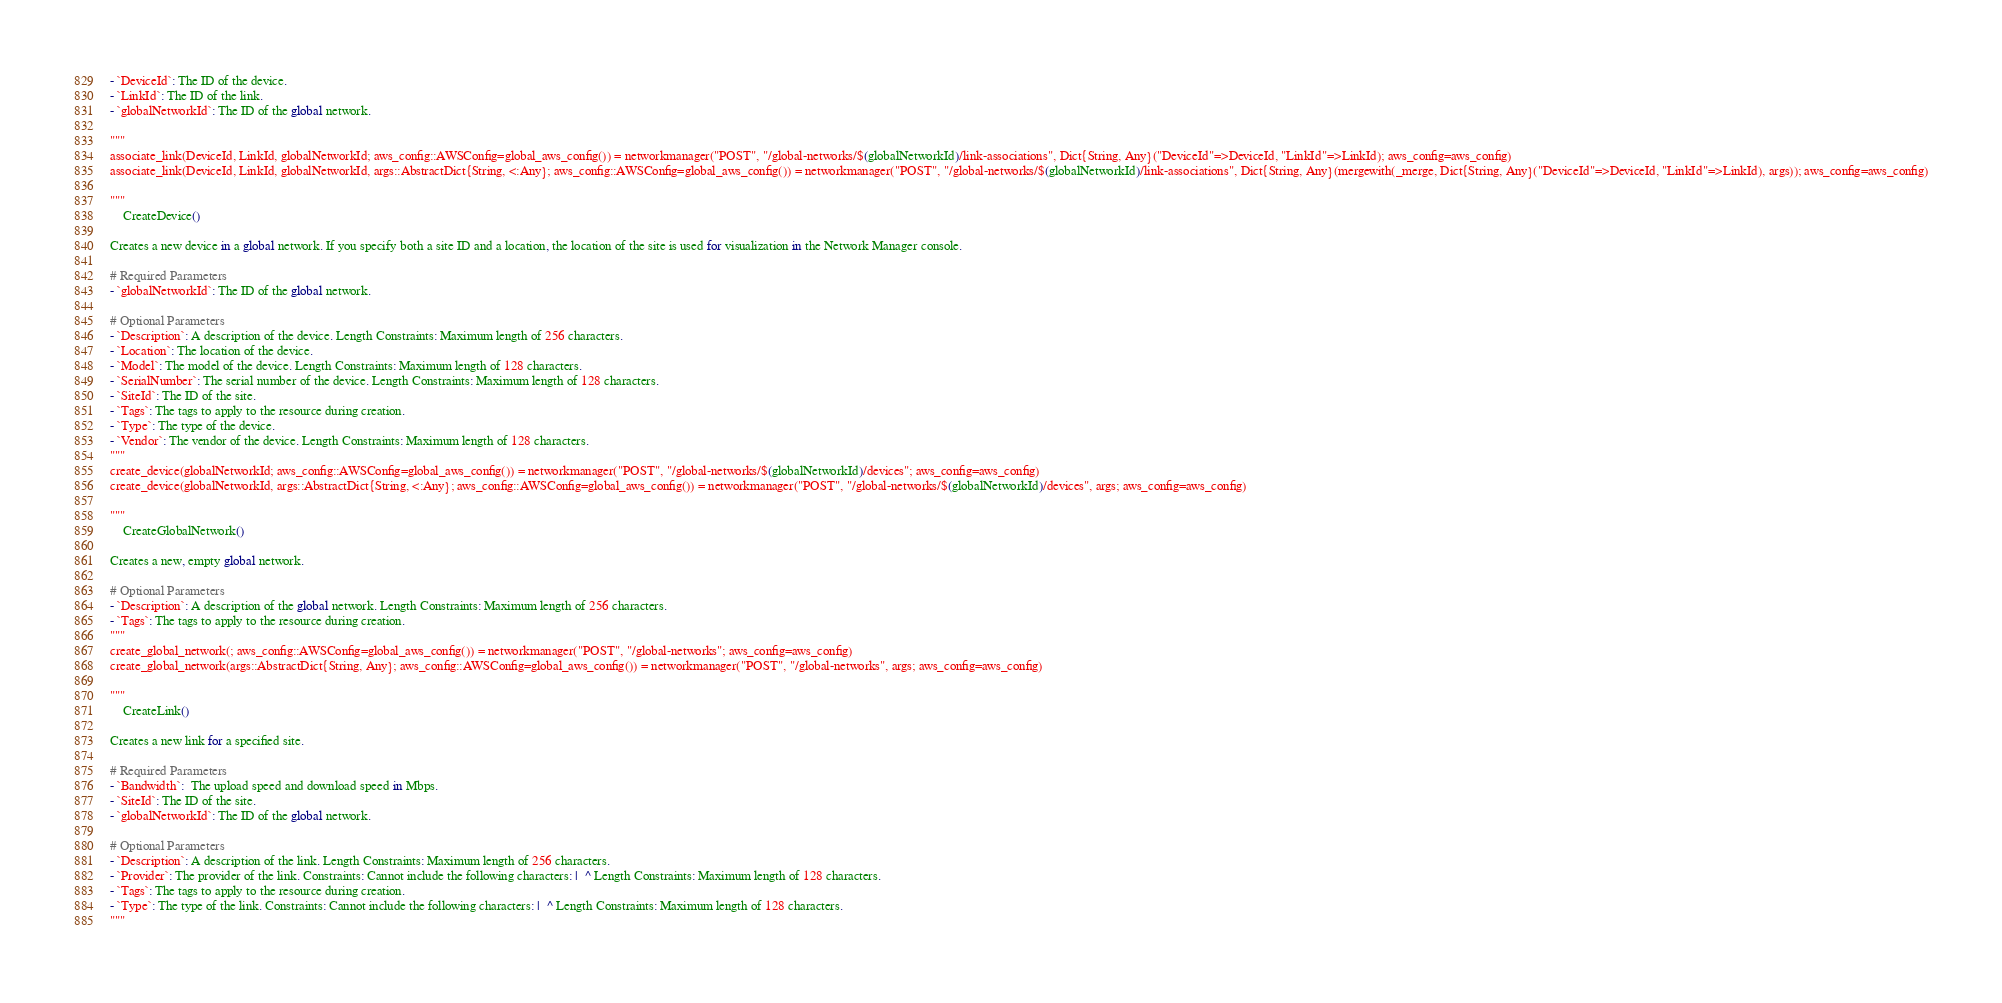Convert code to text. <code><loc_0><loc_0><loc_500><loc_500><_Julia_>- `DeviceId`: The ID of the device.
- `LinkId`: The ID of the link.
- `globalNetworkId`: The ID of the global network.

"""
associate_link(DeviceId, LinkId, globalNetworkId; aws_config::AWSConfig=global_aws_config()) = networkmanager("POST", "/global-networks/$(globalNetworkId)/link-associations", Dict{String, Any}("DeviceId"=>DeviceId, "LinkId"=>LinkId); aws_config=aws_config)
associate_link(DeviceId, LinkId, globalNetworkId, args::AbstractDict{String, <:Any}; aws_config::AWSConfig=global_aws_config()) = networkmanager("POST", "/global-networks/$(globalNetworkId)/link-associations", Dict{String, Any}(mergewith(_merge, Dict{String, Any}("DeviceId"=>DeviceId, "LinkId"=>LinkId), args)); aws_config=aws_config)

"""
    CreateDevice()

Creates a new device in a global network. If you specify both a site ID and a location, the location of the site is used for visualization in the Network Manager console.

# Required Parameters
- `globalNetworkId`: The ID of the global network.

# Optional Parameters
- `Description`: A description of the device. Length Constraints: Maximum length of 256 characters.
- `Location`: The location of the device.
- `Model`: The model of the device. Length Constraints: Maximum length of 128 characters.
- `SerialNumber`: The serial number of the device. Length Constraints: Maximum length of 128 characters.
- `SiteId`: The ID of the site.
- `Tags`: The tags to apply to the resource during creation.
- `Type`: The type of the device.
- `Vendor`: The vendor of the device. Length Constraints: Maximum length of 128 characters.
"""
create_device(globalNetworkId; aws_config::AWSConfig=global_aws_config()) = networkmanager("POST", "/global-networks/$(globalNetworkId)/devices"; aws_config=aws_config)
create_device(globalNetworkId, args::AbstractDict{String, <:Any}; aws_config::AWSConfig=global_aws_config()) = networkmanager("POST", "/global-networks/$(globalNetworkId)/devices", args; aws_config=aws_config)

"""
    CreateGlobalNetwork()

Creates a new, empty global network.

# Optional Parameters
- `Description`: A description of the global network. Length Constraints: Maximum length of 256 characters.
- `Tags`: The tags to apply to the resource during creation.
"""
create_global_network(; aws_config::AWSConfig=global_aws_config()) = networkmanager("POST", "/global-networks"; aws_config=aws_config)
create_global_network(args::AbstractDict{String, Any}; aws_config::AWSConfig=global_aws_config()) = networkmanager("POST", "/global-networks", args; aws_config=aws_config)

"""
    CreateLink()

Creates a new link for a specified site.

# Required Parameters
- `Bandwidth`:  The upload speed and download speed in Mbps. 
- `SiteId`: The ID of the site.
- `globalNetworkId`: The ID of the global network.

# Optional Parameters
- `Description`: A description of the link. Length Constraints: Maximum length of 256 characters.
- `Provider`: The provider of the link. Constraints: Cannot include the following characters: |  ^ Length Constraints: Maximum length of 128 characters.
- `Tags`: The tags to apply to the resource during creation.
- `Type`: The type of the link. Constraints: Cannot include the following characters: |  ^ Length Constraints: Maximum length of 128 characters.
"""</code> 